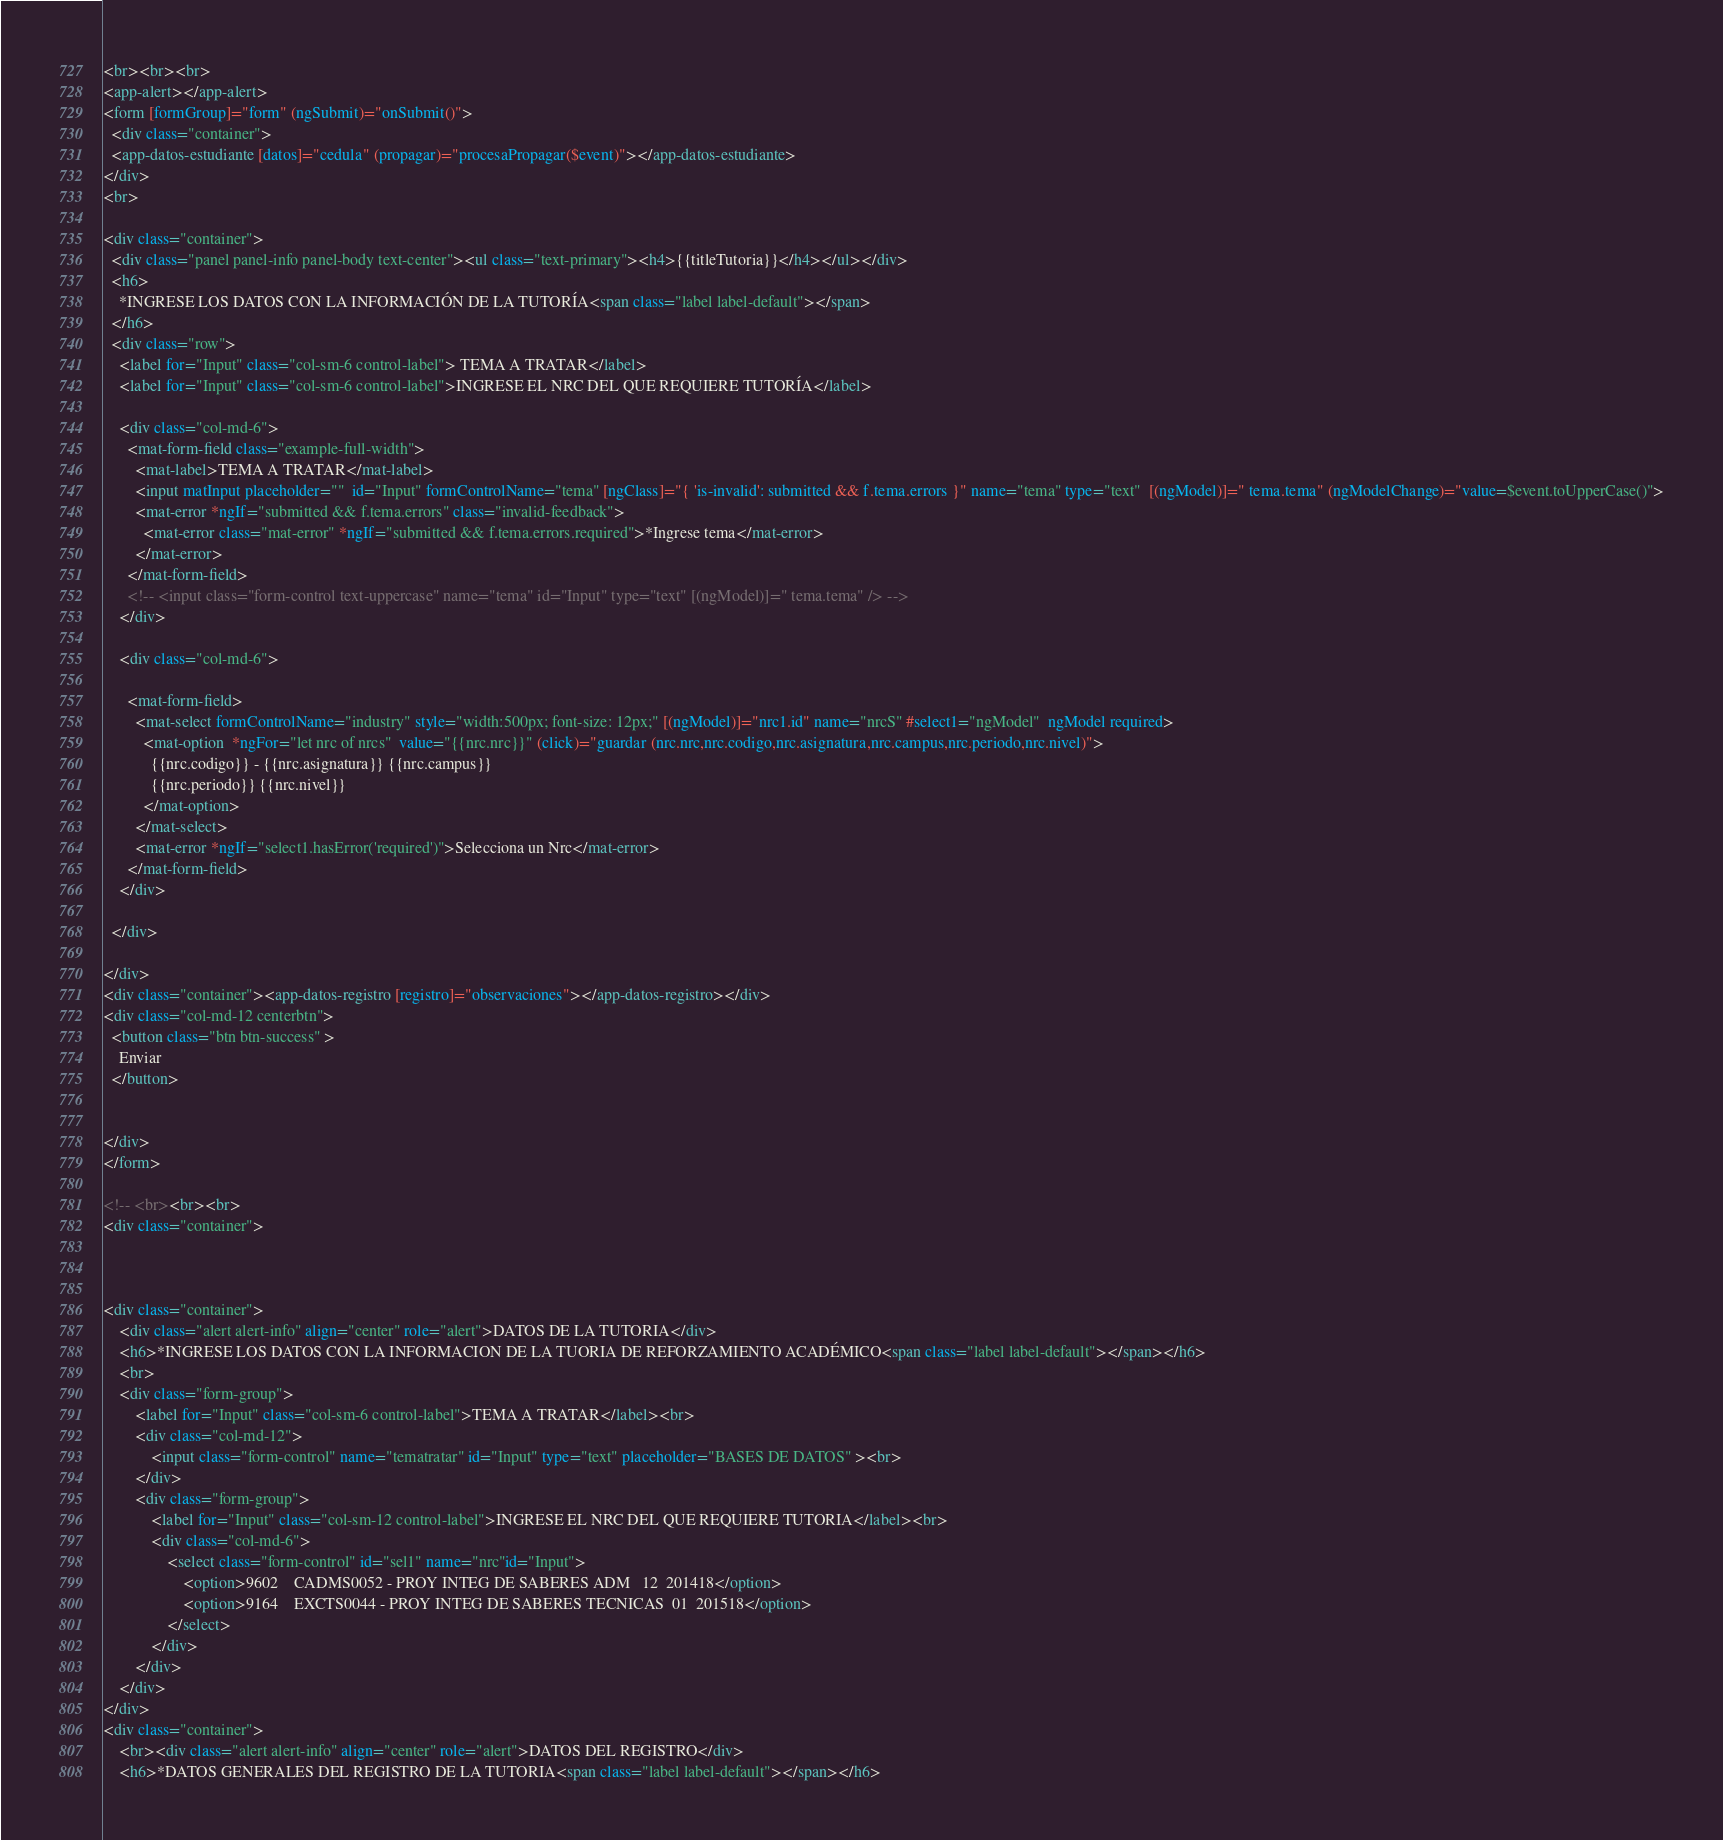Convert code to text. <code><loc_0><loc_0><loc_500><loc_500><_HTML_><br><br><br>
<app-alert></app-alert>
<form [formGroup]="form" (ngSubmit)="onSubmit()">
  <div class="container">
  <app-datos-estudiante [datos]="cedula" (propagar)="procesaPropagar($event)"></app-datos-estudiante>
</div>
<br>

<div class="container">
  <div class="panel panel-info panel-body text-center"><ul class="text-primary"><h4>{{titleTutoria}}</h4></ul></div>
  <h6>
    *INGRESE LOS DATOS CON LA INFORMACIÓN DE LA TUTORÍA<span class="label label-default"></span>
  </h6>
  <div class="row">
    <label for="Input" class="col-sm-6 control-label"> TEMA A TRATAR</label>
    <label for="Input" class="col-sm-6 control-label">INGRESE EL NRC DEL QUE REQUIERE TUTORÍA</label>

    <div class="col-md-6">
      <mat-form-field class="example-full-width">
        <mat-label>TEMA A TRATAR</mat-label>
        <input matInput placeholder=""  id="Input" formControlName="tema" [ngClass]="{ 'is-invalid': submitted && f.tema.errors }" name="tema" type="text"  [(ngModel)]=" tema.tema" (ngModelChange)="value=$event.toUpperCase()">
        <mat-error *ngIf="submitted && f.tema.errors" class="invalid-feedback">
          <mat-error class="mat-error" *ngIf="submitted && f.tema.errors.required">*Ingrese tema</mat-error>
        </mat-error>
      </mat-form-field>
      <!-- <input class="form-control text-uppercase" name="tema" id="Input" type="text" [(ngModel)]=" tema.tema" /> -->
    </div>

    <div class="col-md-6">

      <mat-form-field>
        <mat-select formControlName="industry" style="width:500px; font-size: 12px;" [(ngModel)]="nrc1.id" name="nrcS" #select1="ngModel"  ngModel required>
          <mat-option  *ngFor="let nrc of nrcs"  value="{{nrc.nrc}}" (click)="guardar (nrc.nrc,nrc.codigo,nrc.asignatura,nrc.campus,nrc.periodo,nrc.nivel)">
            {{nrc.codigo}} - {{nrc.asignatura}} {{nrc.campus}} 
            {{nrc.periodo}} {{nrc.nivel}}
          </mat-option>
        </mat-select>
        <mat-error *ngIf="select1.hasError('required')">Selecciona un Nrc</mat-error>
      </mat-form-field>
    </div>
    
  </div>

</div>
<div class="container"><app-datos-registro [registro]="observaciones"></app-datos-registro></div>
<div class="col-md-12 centerbtn">
  <button class="btn btn-success" >
    Enviar
  </button>


</div>
</form>

<!-- <br><br><br> 
<div class="container">
  
   

<div class="container">
    <div class="alert alert-info" align="center" role="alert">DATOS DE LA TUTORIA</div>
    <h6>*INGRESE LOS DATOS CON LA INFORMACION DE LA TUORIA DE REFORZAMIENTO ACADÉMICO<span class="label label-default"></span></h6>
    <br>
    <div class="form-group">
        <label for="Input" class="col-sm-6 control-label">TEMA A TRATAR</label><br>
        <div class="col-md-12">
            <input class="form-control" name="tematratar" id="Input" type="text" placeholder="BASES DE DATOS" ><br>
        </div>
        <div class="form-group">
            <label for="Input" class="col-sm-12 control-label">INGRESE EL NRC DEL QUE REQUIERE TUTORIA</label><br>
            <div class="col-md-6">
                <select class="form-control" id="sel1" name="nrc"id="Input">
                    <option>9602	CADMS0052 - PROY INTEG DE SABERES ADM	12	201418</option>
                    <option>9164	EXCTS0044 - PROY INTEG DE SABERES TECNICAS	01	201518</option>
                </select>
            </div>
        </div>
    </div>
</div>
<div class="container">
    <br><div class="alert alert-info" align="center" role="alert">DATOS DEL REGISTRO</div>
    <h6>*DATOS GENERALES DEL REGISTRO DE LA TUTORIA<span class="label label-default"></span></h6></code> 